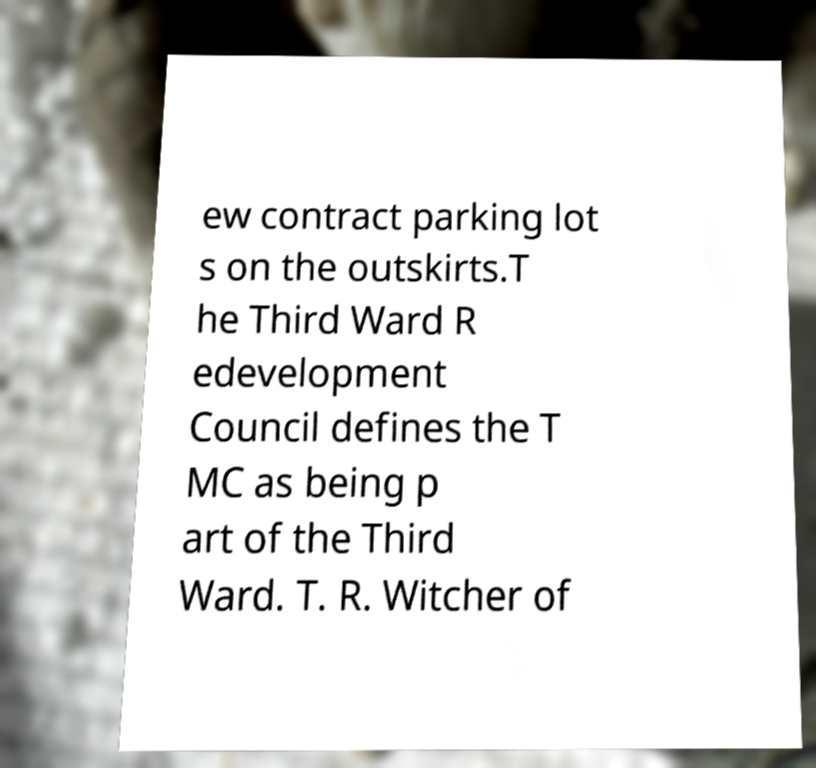Please read and relay the text visible in this image. What does it say? ew contract parking lot s on the outskirts.T he Third Ward R edevelopment Council defines the T MC as being p art of the Third Ward. T. R. Witcher of 